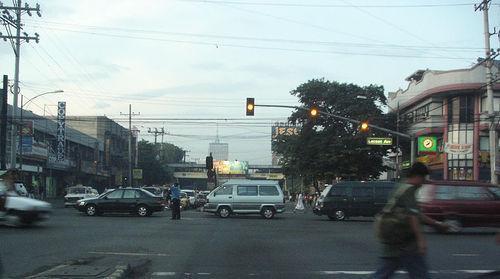How many lights are in this picture?
Give a very brief answer. 3. 